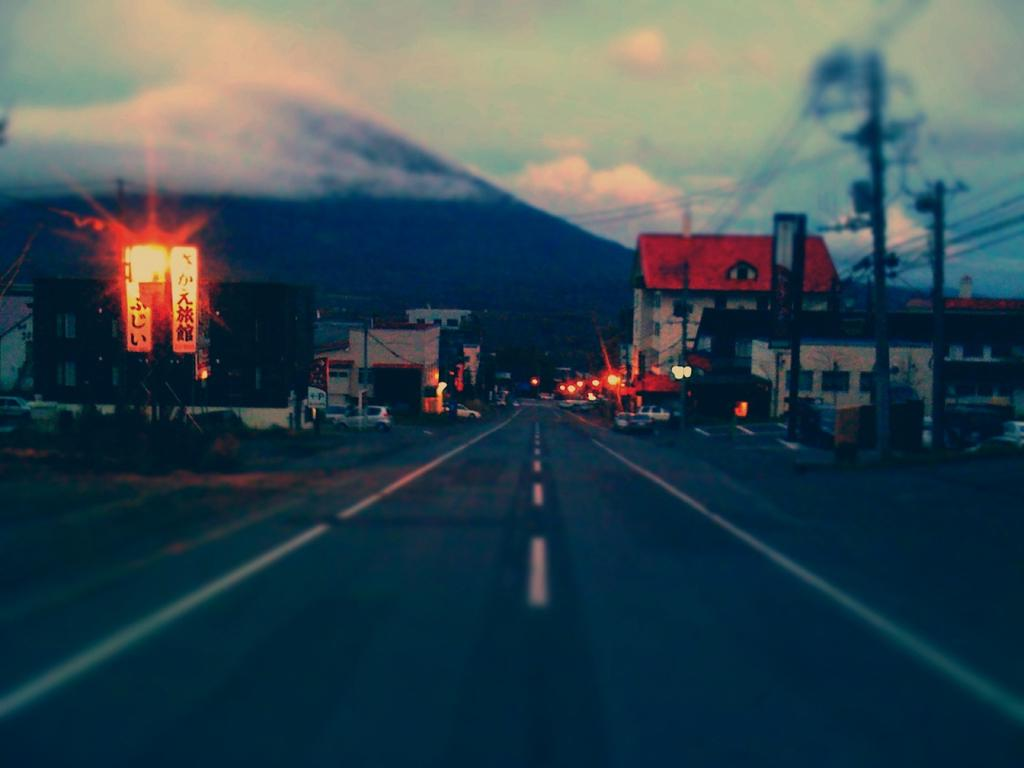What is in the foreground of the image? There is a road in the foreground of the image. What is on either side of the road? There are buildings on either side of the road. What objects can be seen in the image besides the road and buildings? There are poles, boards, and vehicles visible in the image. What can be seen in the background of the image? There is a mountain and sky visible in the background of the image. What advice does the minister give to the hose in the image? There is no minister or hose present in the image, so it is not possible to answer that question. 